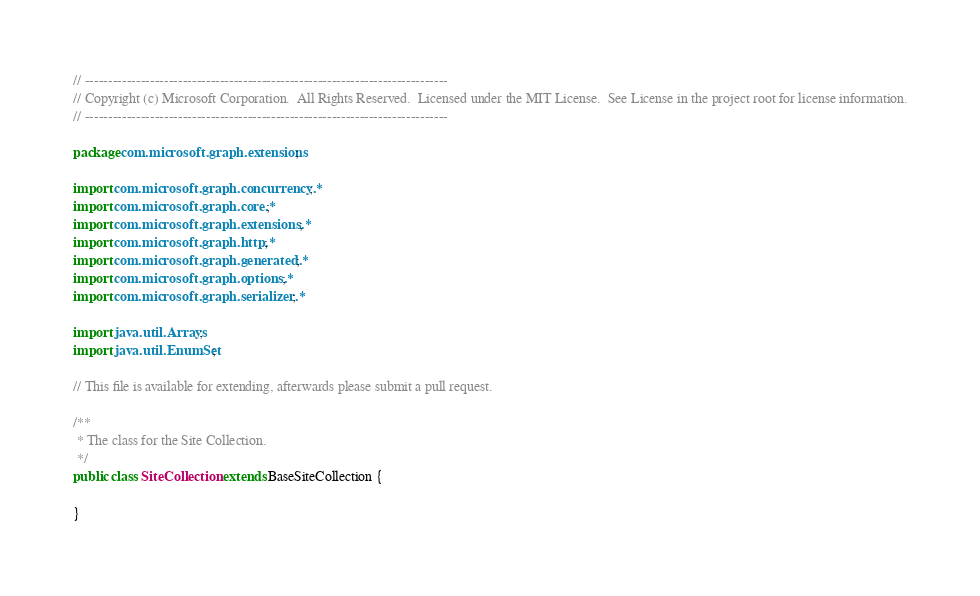Convert code to text. <code><loc_0><loc_0><loc_500><loc_500><_Java_>// ------------------------------------------------------------------------------
// Copyright (c) Microsoft Corporation.  All Rights Reserved.  Licensed under the MIT License.  See License in the project root for license information.
// ------------------------------------------------------------------------------

package com.microsoft.graph.extensions;

import com.microsoft.graph.concurrency.*;
import com.microsoft.graph.core.*;
import com.microsoft.graph.extensions.*;
import com.microsoft.graph.http.*;
import com.microsoft.graph.generated.*;
import com.microsoft.graph.options.*;
import com.microsoft.graph.serializer.*;

import java.util.Arrays;
import java.util.EnumSet;

// This file is available for extending, afterwards please submit a pull request.

/**
 * The class for the Site Collection.
 */
public class SiteCollection extends BaseSiteCollection {

}
</code> 